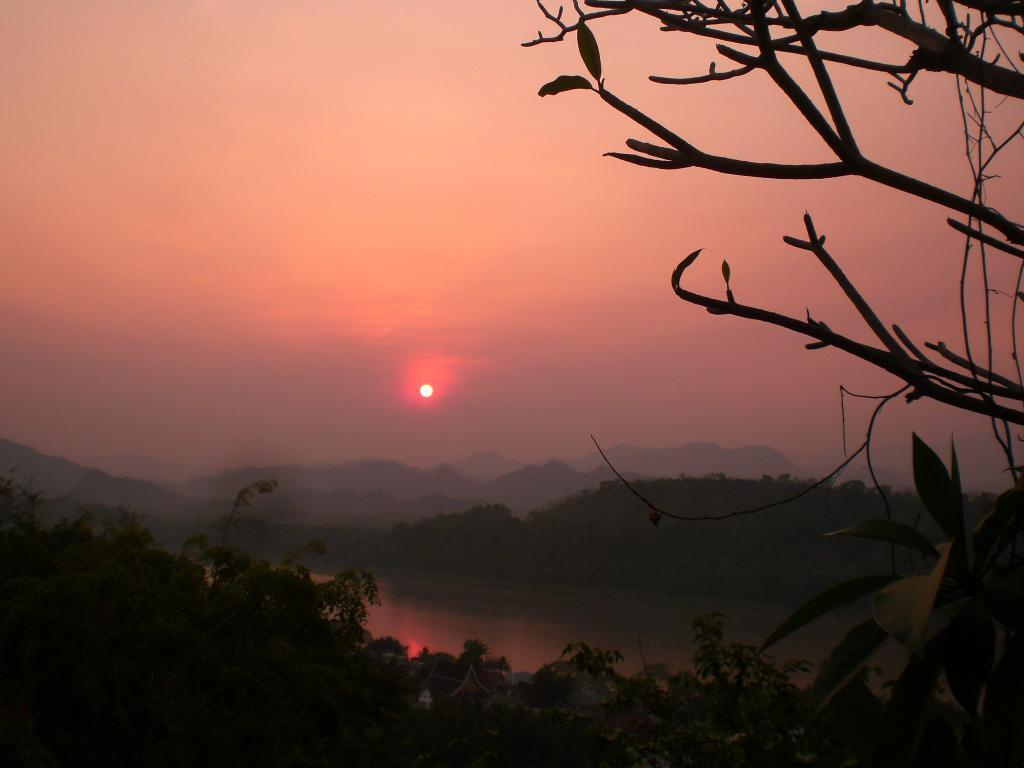What type of natural elements can be seen in the image? There are trees in the image. What type of man-made structures are present in the image? There are houses in the image. What body of water is visible in the image? There is water visible in the image. What type of landscape feature can be seen in the background of the image? There are hills in the background of the image. What part of the natural environment is visible in the background of the image? The sky is visible in the background of the image. What additional details can be seen on the right side of the image? There are leaves and branches on the right side of the image. What type of plot is being used to grow the trees in the image? There is no information about a plot or any gardening techniques in the image, as it simply shows trees in their natural environment. Can you tell me how many books are stacked on the table in the image? There is no table or books present in the image; it features trees, houses, water, hills, and the sky. 